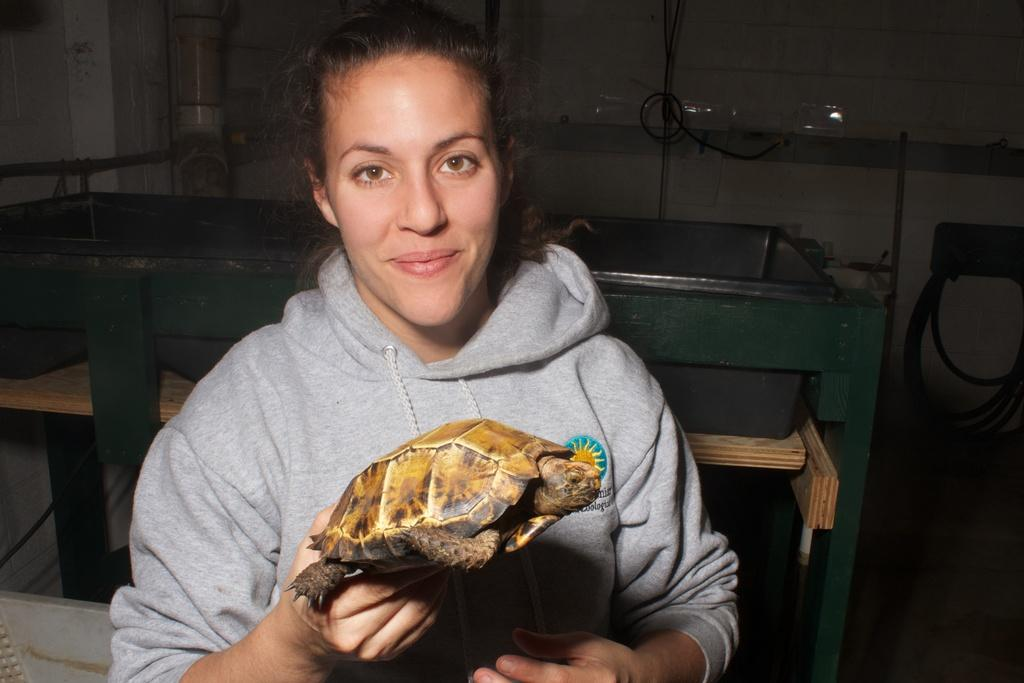Who is present in the image? There is a woman in the image. What is the woman holding in the image? The woman is holding a tortoise. What can be seen in the background of the image? There is a wall and a pipe in the background of the image, along with some objects. What type of bubble can be seen in the image? There is no bubble present in the image. 